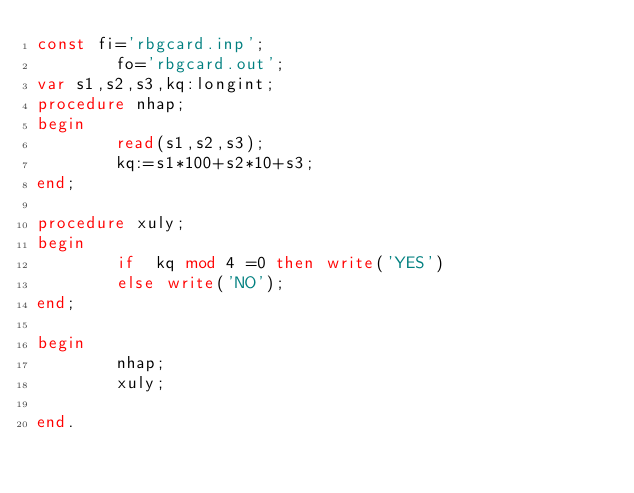<code> <loc_0><loc_0><loc_500><loc_500><_Pascal_>const fi='rbgcard.inp';
        fo='rbgcard.out';
var s1,s2,s3,kq:longint;
procedure nhap;
begin
        read(s1,s2,s3);
        kq:=s1*100+s2*10+s3;
end;

procedure xuly;
begin
        if  kq mod 4 =0 then write('YES')
        else write('NO');
end;

begin
        nhap;
        xuly;

end.</code> 